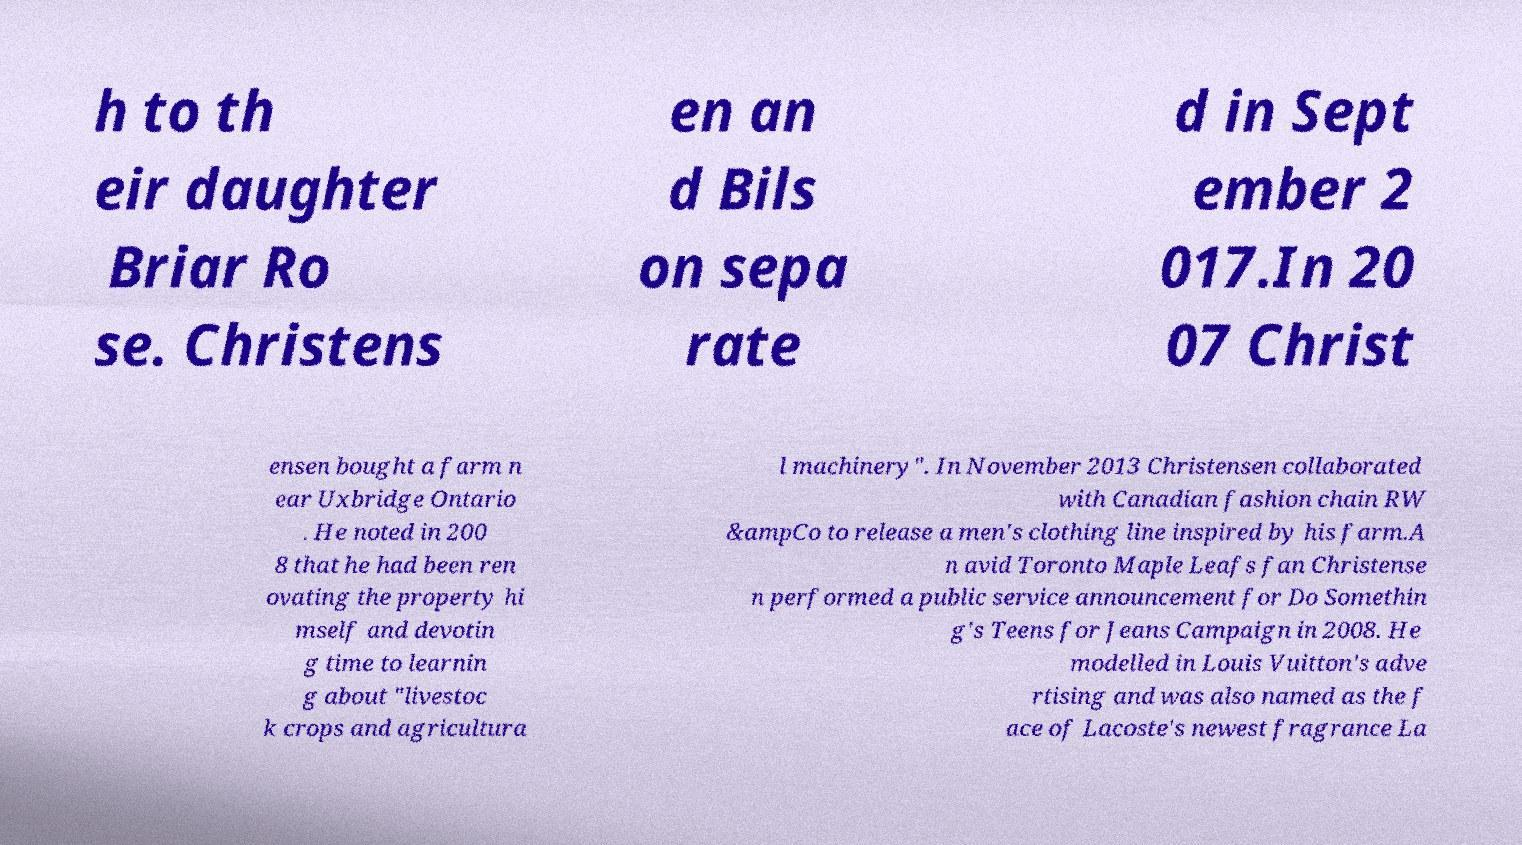Could you extract and type out the text from this image? h to th eir daughter Briar Ro se. Christens en an d Bils on sepa rate d in Sept ember 2 017.In 20 07 Christ ensen bought a farm n ear Uxbridge Ontario . He noted in 200 8 that he had been ren ovating the property hi mself and devotin g time to learnin g about "livestoc k crops and agricultura l machinery". In November 2013 Christensen collaborated with Canadian fashion chain RW &ampCo to release a men's clothing line inspired by his farm.A n avid Toronto Maple Leafs fan Christense n performed a public service announcement for Do Somethin g's Teens for Jeans Campaign in 2008. He modelled in Louis Vuitton's adve rtising and was also named as the f ace of Lacoste's newest fragrance La 